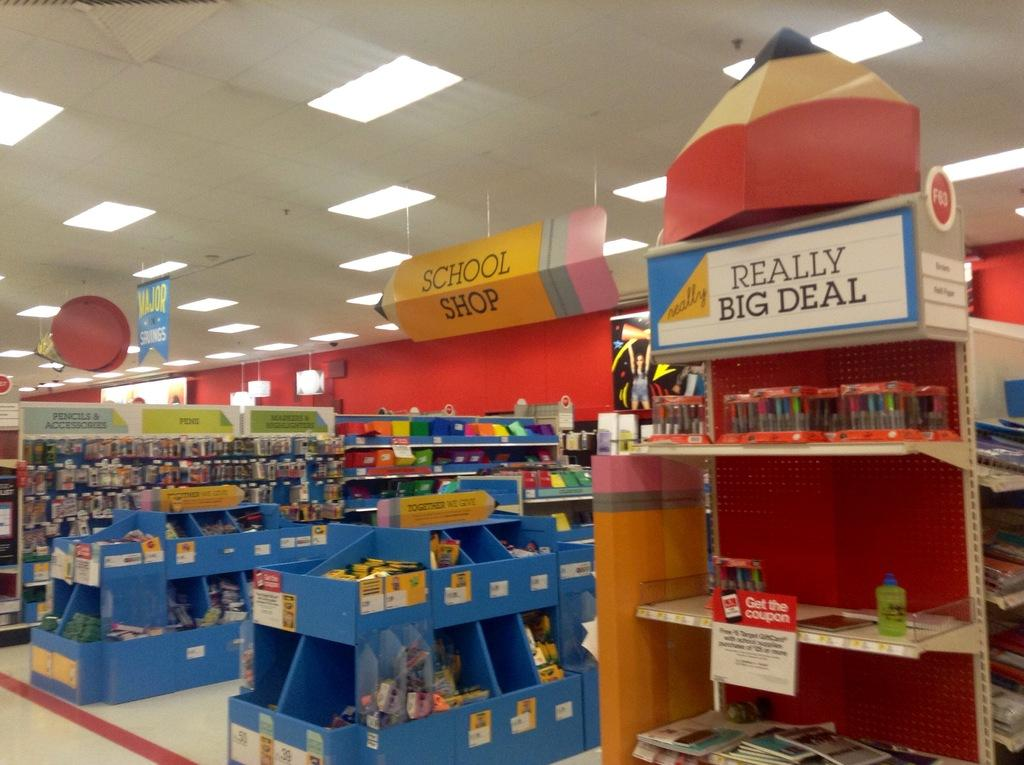<image>
Provide a brief description of the given image. a display section at a store with signs saying School shop and REALLY BIG DEAL. 